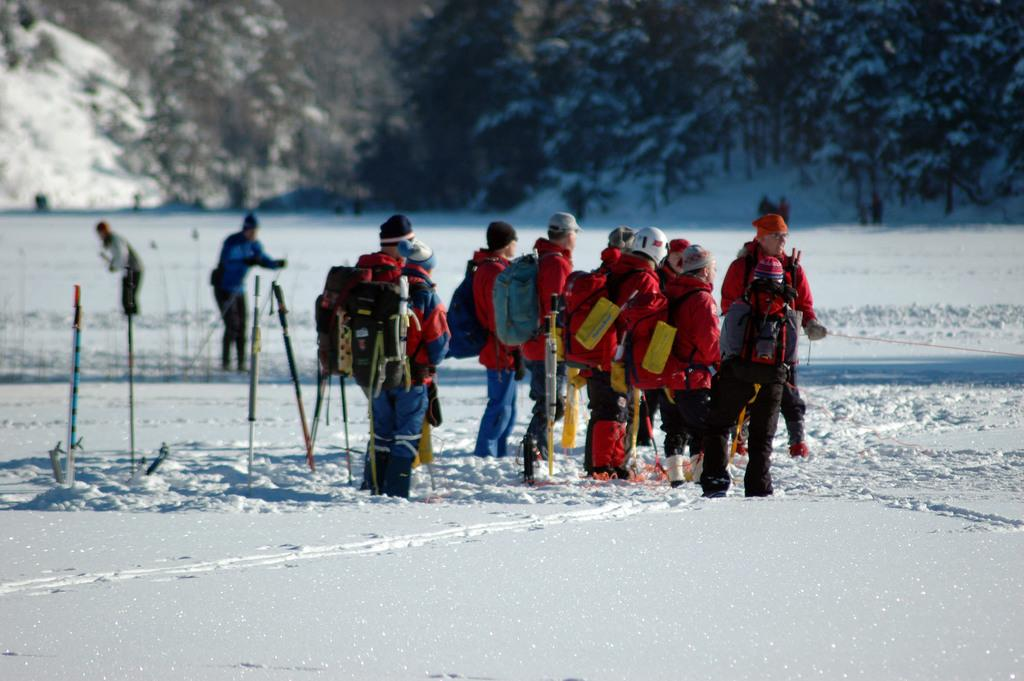Who or what is present in the image? There are people in the image. What are the people wearing? The people are wearing bags. What are the people holding in their hands? The people are holding sticks in their hands. What is the ground made of in the image? There is snow at the bottom of the image. What can be seen in the distance in the image? There are trees in the background of the image. What type of servant can be seen attending to the people in the image? There is no servant present in the image; it only features people wearing bags and holding sticks. What school event might be taking place in the image? There is no indication of a school event in the image; it simply shows people wearing bags and holding sticks in a snowy environment with trees in the background. 